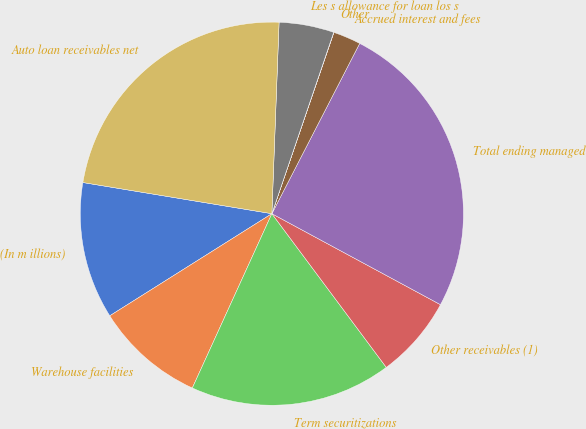<chart> <loc_0><loc_0><loc_500><loc_500><pie_chart><fcel>(In m illions)<fcel>Warehouse facilities<fcel>Term securitizations<fcel>Other receivables (1)<fcel>Total ending managed<fcel>Accrued interest and fees<fcel>Other<fcel>Les s allowance for loan los s<fcel>Auto loan receivables net<nl><fcel>11.55%<fcel>9.24%<fcel>17.0%<fcel>6.94%<fcel>25.3%<fcel>2.33%<fcel>0.02%<fcel>4.63%<fcel>23.0%<nl></chart> 